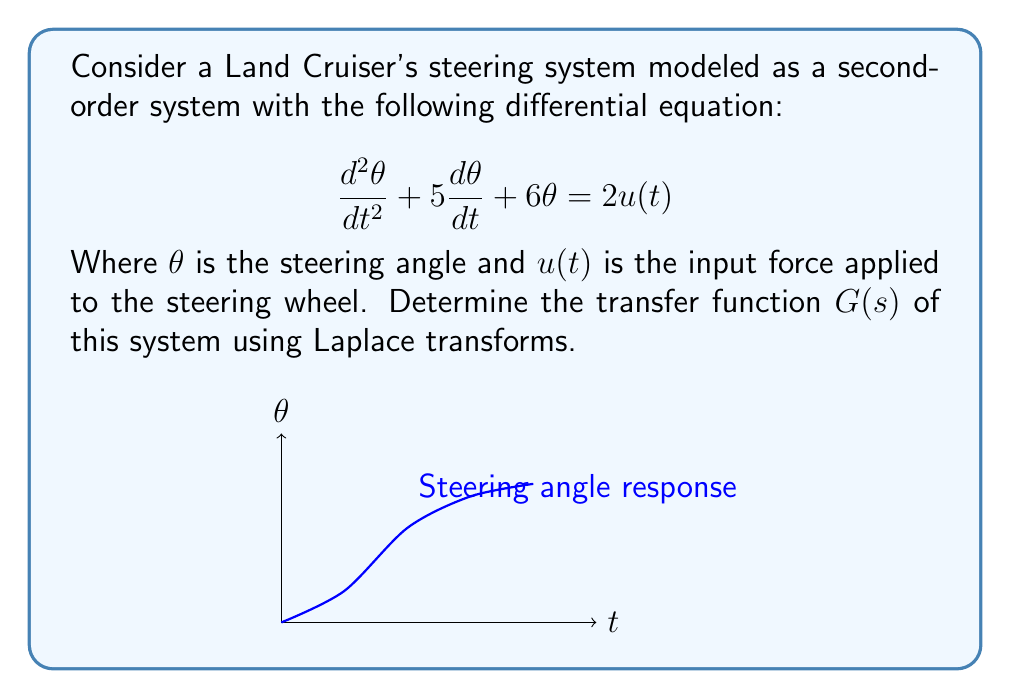Can you solve this math problem? To determine the transfer function using Laplace transforms, we follow these steps:

1) Take the Laplace transform of both sides of the equation:
   $$\mathcal{L}\{\frac{d^2\theta}{dt^2} + 5\frac{d\theta}{dt} + 6\theta\} = \mathcal{L}\{2u(t)\}$$

2) Apply Laplace transform properties:
   $$s^2\Theta(s) - s\theta(0) - \theta'(0) + 5[s\Theta(s) - \theta(0)] + 6\Theta(s) = 2U(s)$$

3) Assume zero initial conditions ($\theta(0) = 0$, $\theta'(0) = 0$):
   $$s^2\Theta(s) + 5s\Theta(s) + 6\Theta(s) = 2U(s)$$

4) Factor out $\Theta(s)$:
   $$(s^2 + 5s + 6)\Theta(s) = 2U(s)$$

5) Solve for $\Theta(s)$:
   $$\Theta(s) = \frac{2U(s)}{s^2 + 5s + 6}$$

6) The transfer function $G(s)$ is defined as the ratio of output to input in the s-domain:
   $$G(s) = \frac{\Theta(s)}{U(s)} = \frac{2}{s^2 + 5s + 6}$$

Thus, we have derived the transfer function of the Land Cruiser's steering system.
Answer: $$G(s) = \frac{2}{s^2 + 5s + 6}$$ 